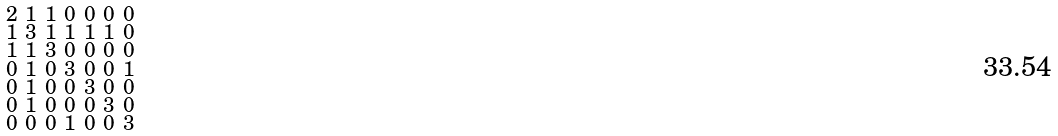Convert formula to latex. <formula><loc_0><loc_0><loc_500><loc_500>\begin{smallmatrix} 2 & 1 & 1 & 0 & 0 & 0 & 0 \\ 1 & 3 & 1 & 1 & 1 & 1 & 0 \\ 1 & 1 & 3 & 0 & 0 & 0 & 0 \\ 0 & 1 & 0 & 3 & 0 & 0 & 1 \\ 0 & 1 & 0 & 0 & 3 & 0 & 0 \\ 0 & 1 & 0 & 0 & 0 & 3 & 0 \\ 0 & 0 & 0 & 1 & 0 & 0 & 3 \end{smallmatrix}</formula> 